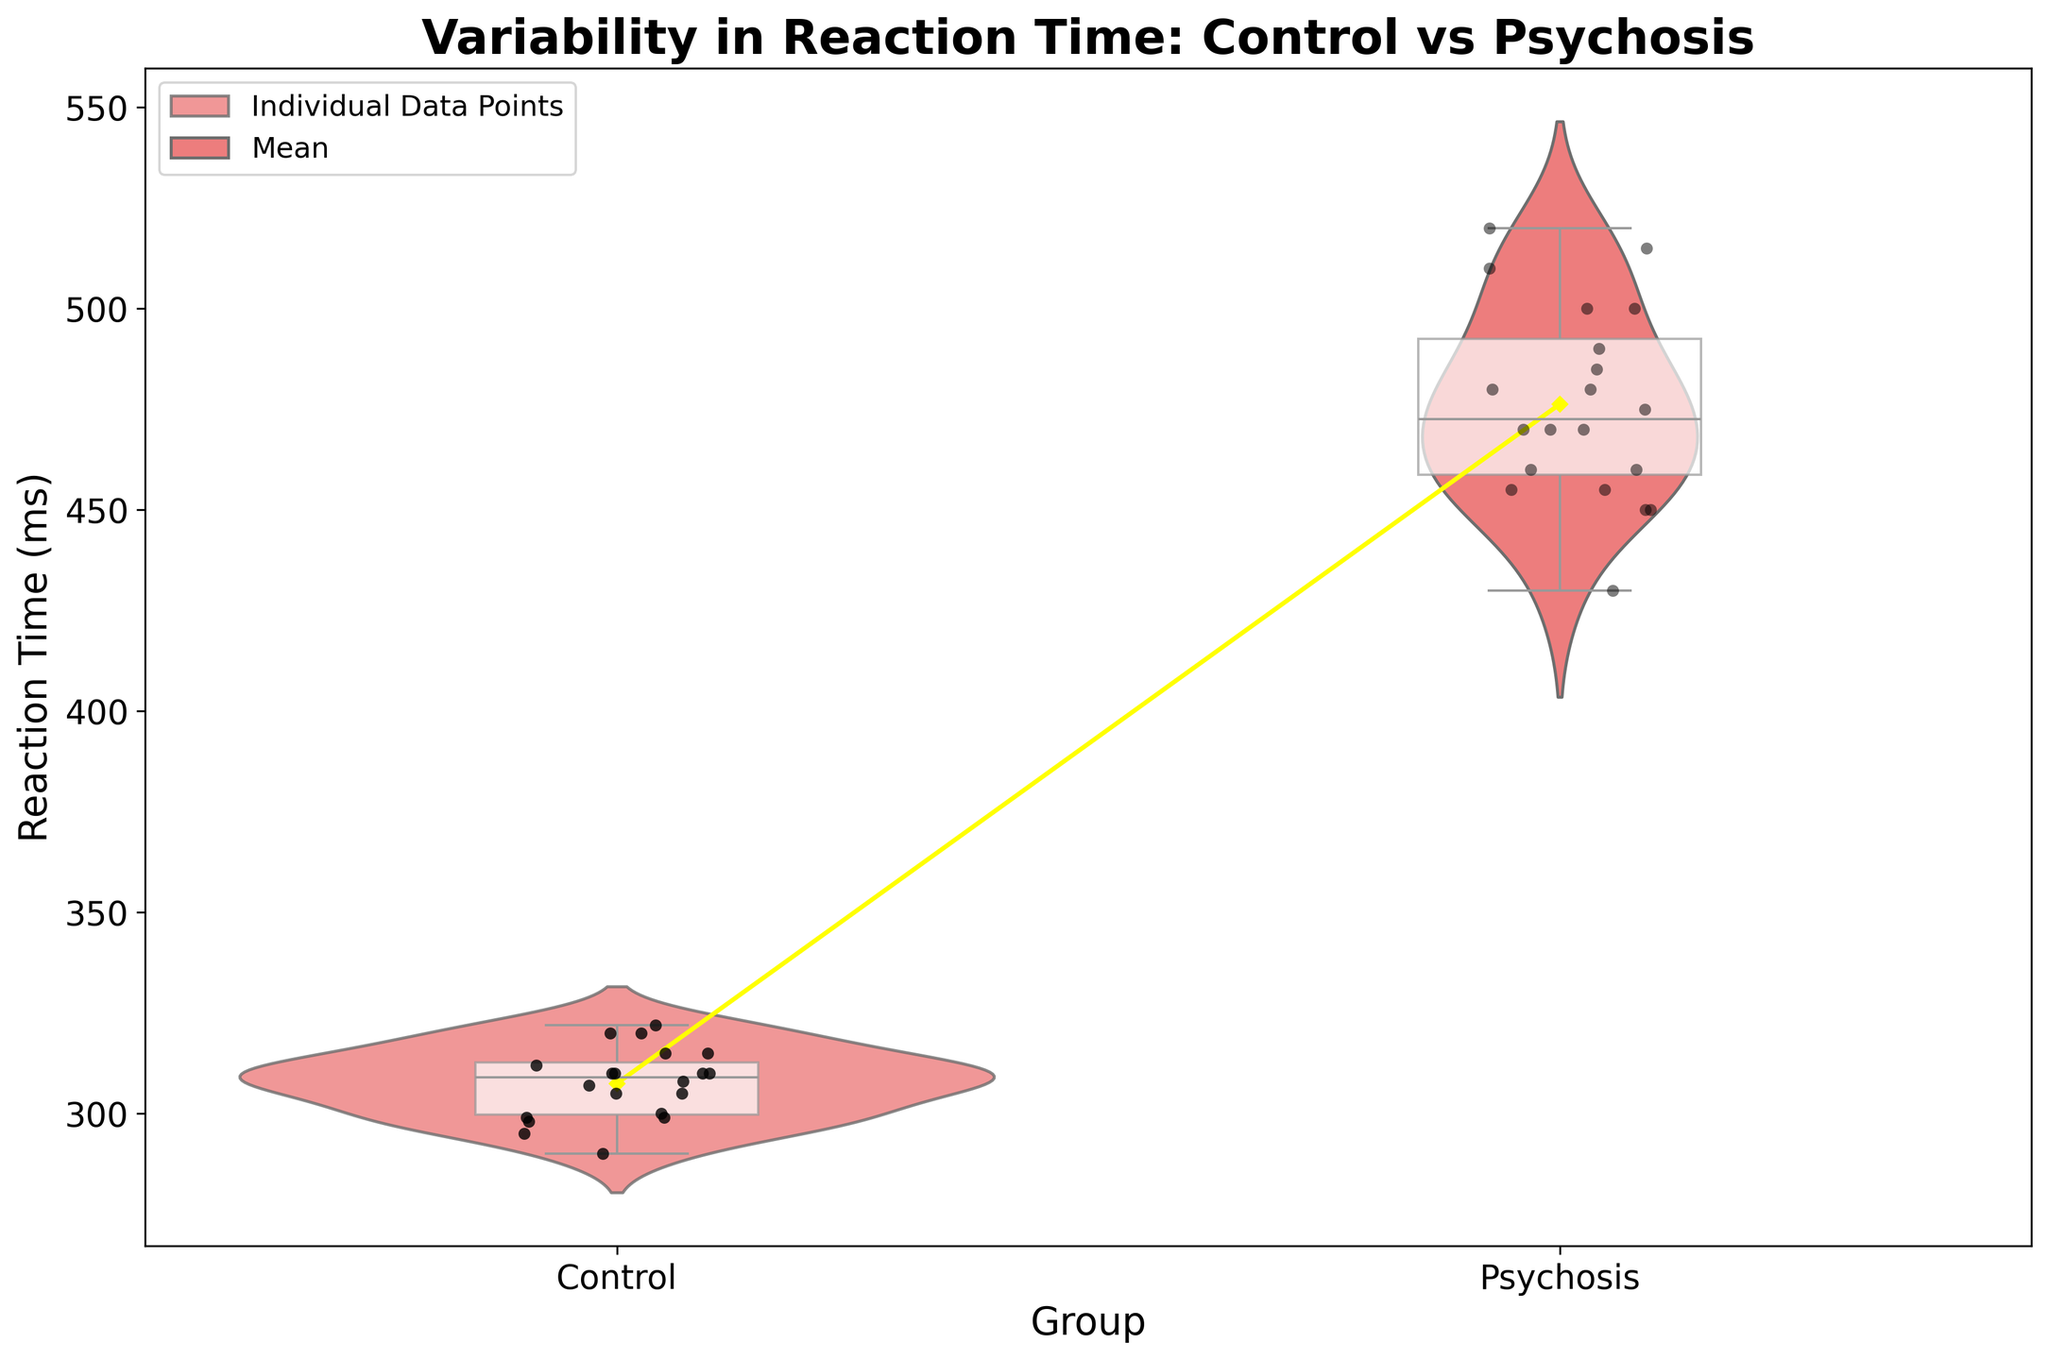what's the title of the plot? The title of the plot is usually found at the top and indicates what the figure represents.
Answer: Variability in Reaction Time: Control vs Psychosis what are the labels of the x-axis and y-axis? The x-axis label describes the grouping variable and is essential to identify how data are categorized, while the y-axis label describes the measurement variable.
Answer: Group, Reaction Time (ms) which group shows a greater spread in reaction times? The spread of the reaction times can be identified by looking at the width and shape of the violin plot and the range of the box plot within each group.
Answer: Psychosis what color represents the 'Control' group, and what color represents the 'Psychosis' group? The colors of the groups are indicated by the color palette in the violin plots.
Answer: Control: Red, Psychosis: Teal what's the median reaction time for the 'Psychosis' group? The median is the line inside the box in the box plot representing the reaction times of the 'Psychosis' group.
Answer: Approximately 470 ms what's the median reaction time for the 'Control' group? The median is the line inside the box in the box plot representing the reaction times of the 'Control' group.
Answer: Approximately 310 ms which group has the largest individual reaction time? The individual reaction times are shown as black jittered points, and the highest point indicates the group with the largest reaction time.
Answer: Psychosis how do the means of the two groups compare? The means are represented by the yellow diamond markers. Compare the positions of these markers for each group.
Answer: The mean reaction time is higher for the Psychosis group what's the interquartile range (IQR) for the 'Control' group? The IQR is the range between the first and third quartiles, represented by the edges of the box in the box plot.
Answer: Approximately 15 ms (from ~300 to ~315 ms) how do the overall reaction time distributions compare between the two groups? The overall distribution can be compared by looking at the shape and spread of the violin plots and box plots for each group.
Answer: The 'Psychosis' group has a wider and higher reaction time distribution compared to the 'Control' group 